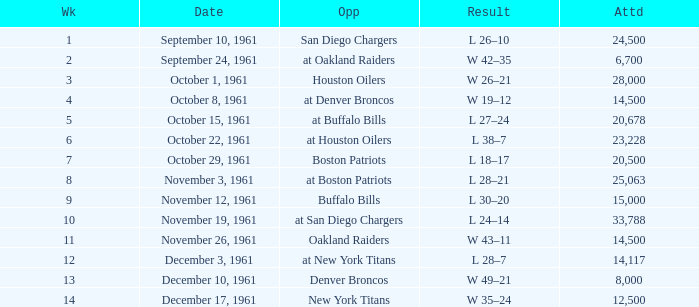What is the low attendance rate against buffalo bills? 15000.0. 